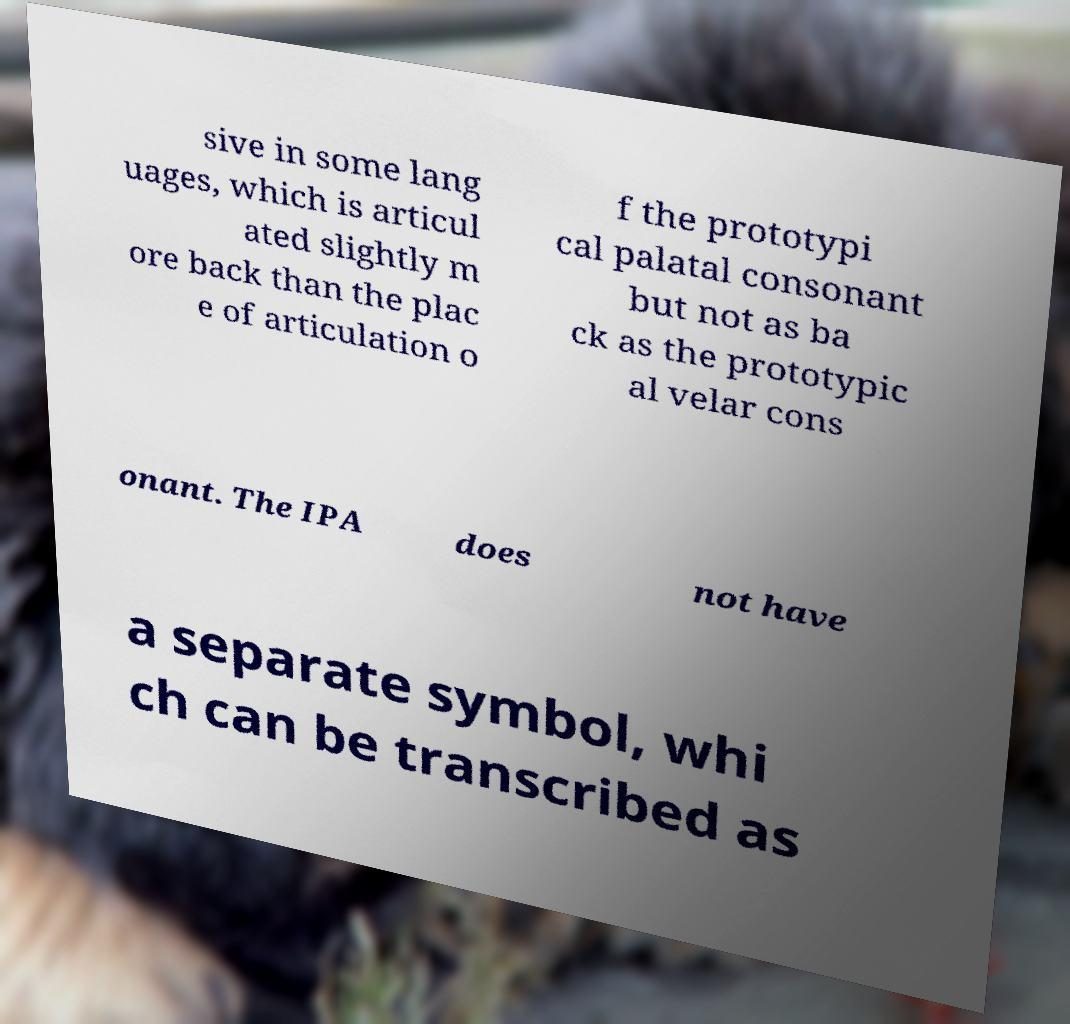What messages or text are displayed in this image? I need them in a readable, typed format. sive in some lang uages, which is articul ated slightly m ore back than the plac e of articulation o f the prototypi cal palatal consonant but not as ba ck as the prototypic al velar cons onant. The IPA does not have a separate symbol, whi ch can be transcribed as 